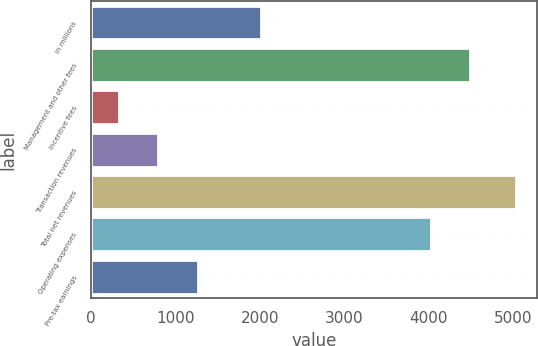Convert chart. <chart><loc_0><loc_0><loc_500><loc_500><bar_chart><fcel>in millions<fcel>Management and other fees<fcel>Incentive fees<fcel>Transaction revenues<fcel>Total net revenues<fcel>Operating expenses<fcel>Pre-tax earnings<nl><fcel>2011<fcel>4491.1<fcel>323<fcel>794.1<fcel>5034<fcel>4020<fcel>1265.2<nl></chart> 